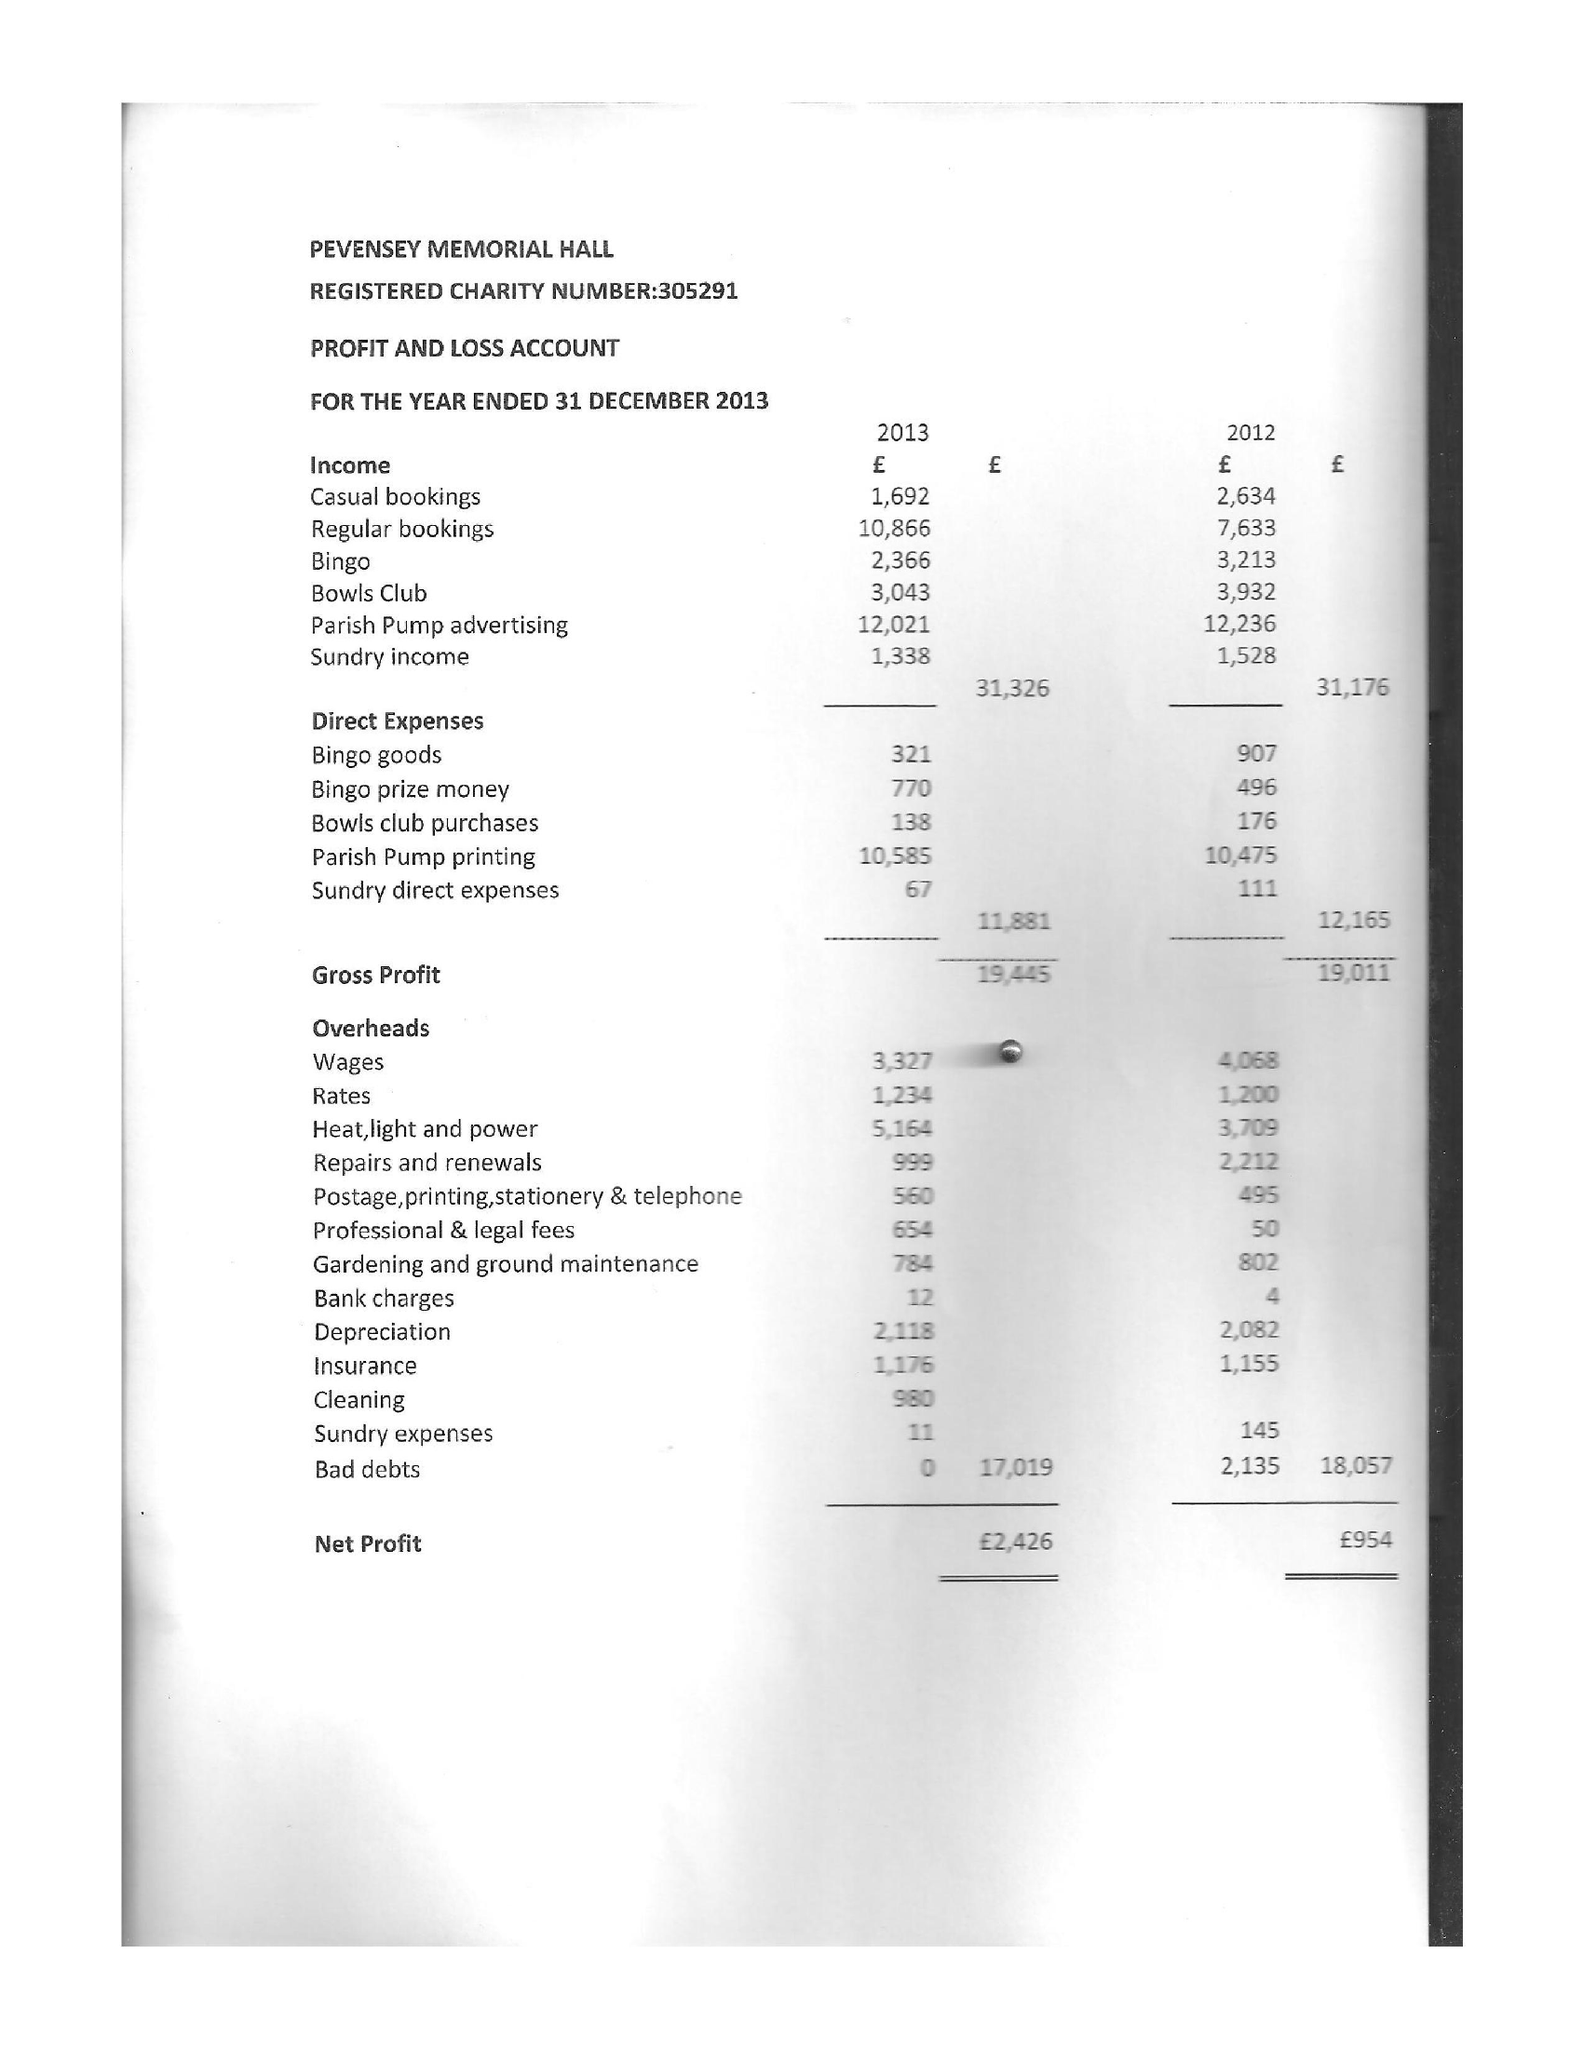What is the value for the income_annually_in_british_pounds?
Answer the question using a single word or phrase. 31326.00 